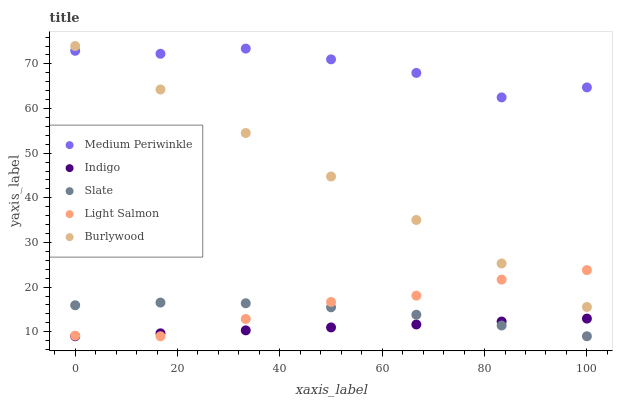Does Indigo have the minimum area under the curve?
Answer yes or no. Yes. Does Medium Periwinkle have the maximum area under the curve?
Answer yes or no. Yes. Does Slate have the minimum area under the curve?
Answer yes or no. No. Does Slate have the maximum area under the curve?
Answer yes or no. No. Is Indigo the smoothest?
Answer yes or no. Yes. Is Medium Periwinkle the roughest?
Answer yes or no. Yes. Is Slate the smoothest?
Answer yes or no. No. Is Slate the roughest?
Answer yes or no. No. Does Indigo have the lowest value?
Answer yes or no. Yes. Does Medium Periwinkle have the lowest value?
Answer yes or no. No. Does Burlywood have the highest value?
Answer yes or no. Yes. Does Slate have the highest value?
Answer yes or no. No. Is Slate less than Burlywood?
Answer yes or no. Yes. Is Medium Periwinkle greater than Slate?
Answer yes or no. Yes. Does Indigo intersect Slate?
Answer yes or no. Yes. Is Indigo less than Slate?
Answer yes or no. No. Is Indigo greater than Slate?
Answer yes or no. No. Does Slate intersect Burlywood?
Answer yes or no. No. 